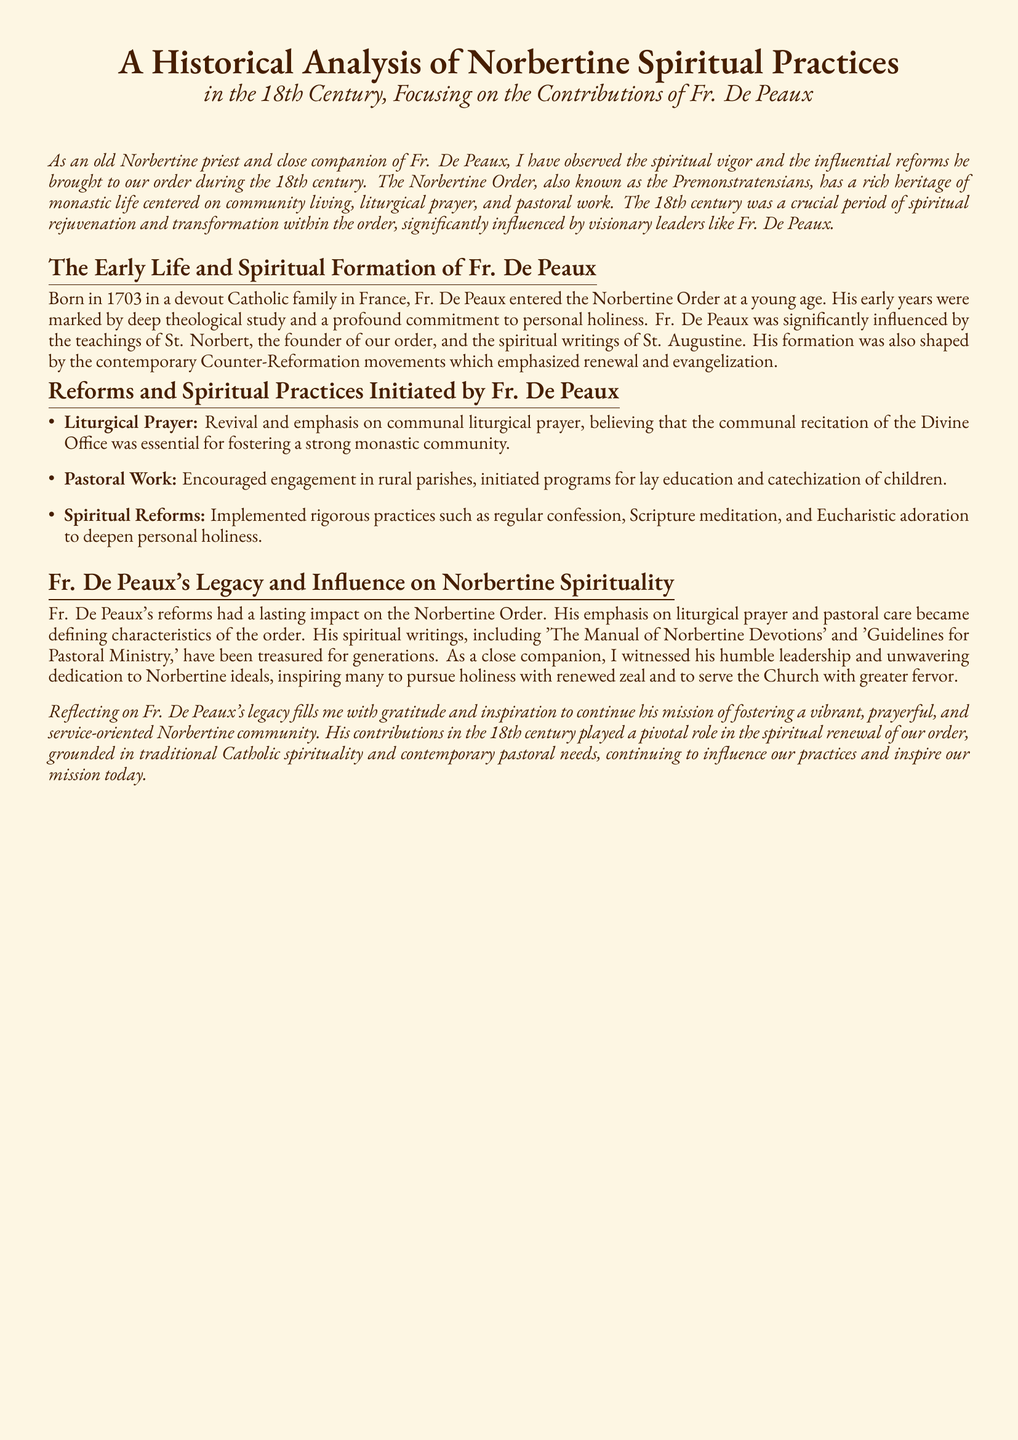What year was Fr. De Peaux born? The document states that Fr. De Peaux was born in 1703.
Answer: 1703 What is the title of one of Fr. De Peaux's spiritual writings? The document mentions 'The Manual of Norbertine Devotions' as one of Fr. De Peaux's spiritual writings.
Answer: The Manual of Norbertine Devotions What reform did Fr. De Peaux emphasize for the monastic community? The document highlights the emphasis on communal liturgical prayer as essential for fostering a strong monastic community.
Answer: Communal liturgical prayer Which saint's teachings significantly influenced Fr. De Peaux? The document indicates that Fr. De Peaux was influenced by the teachings of St. Norbert.
Answer: St. Norbert What was a notable contribution of Fr. De Peaux to lay education? The document states that he initiated programs for lay education and catechization of children.
Answer: Programs for lay education How did Fr. De Peaux’s reforms affect the Norbertine Order? The document explains that his reforms had a lasting impact, becoming defining characteristics of the order.
Answer: Lasting impact What year does the analysis focus on? The analysis specifically focuses on the 18th century regarding Norbertine spiritual practices.
Answer: 18th century What practice was encouraged for personal holiness? The document lists regular confession as one of the rigorous practices implemented by Fr. De Peaux.
Answer: Regular confession 